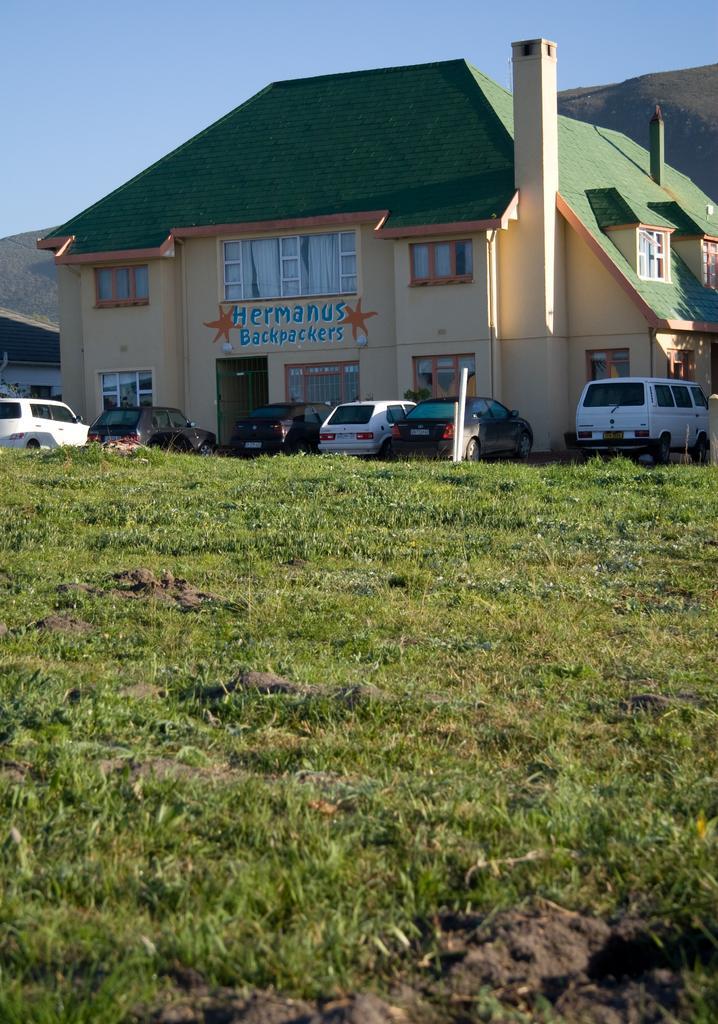In one or two sentences, can you explain what this image depicts? This image consists of many cars parked on the road. In the front, there is a building along with windows. At the bottom, there is green grass. In the background, there is a mountain. At the top there is sky. 